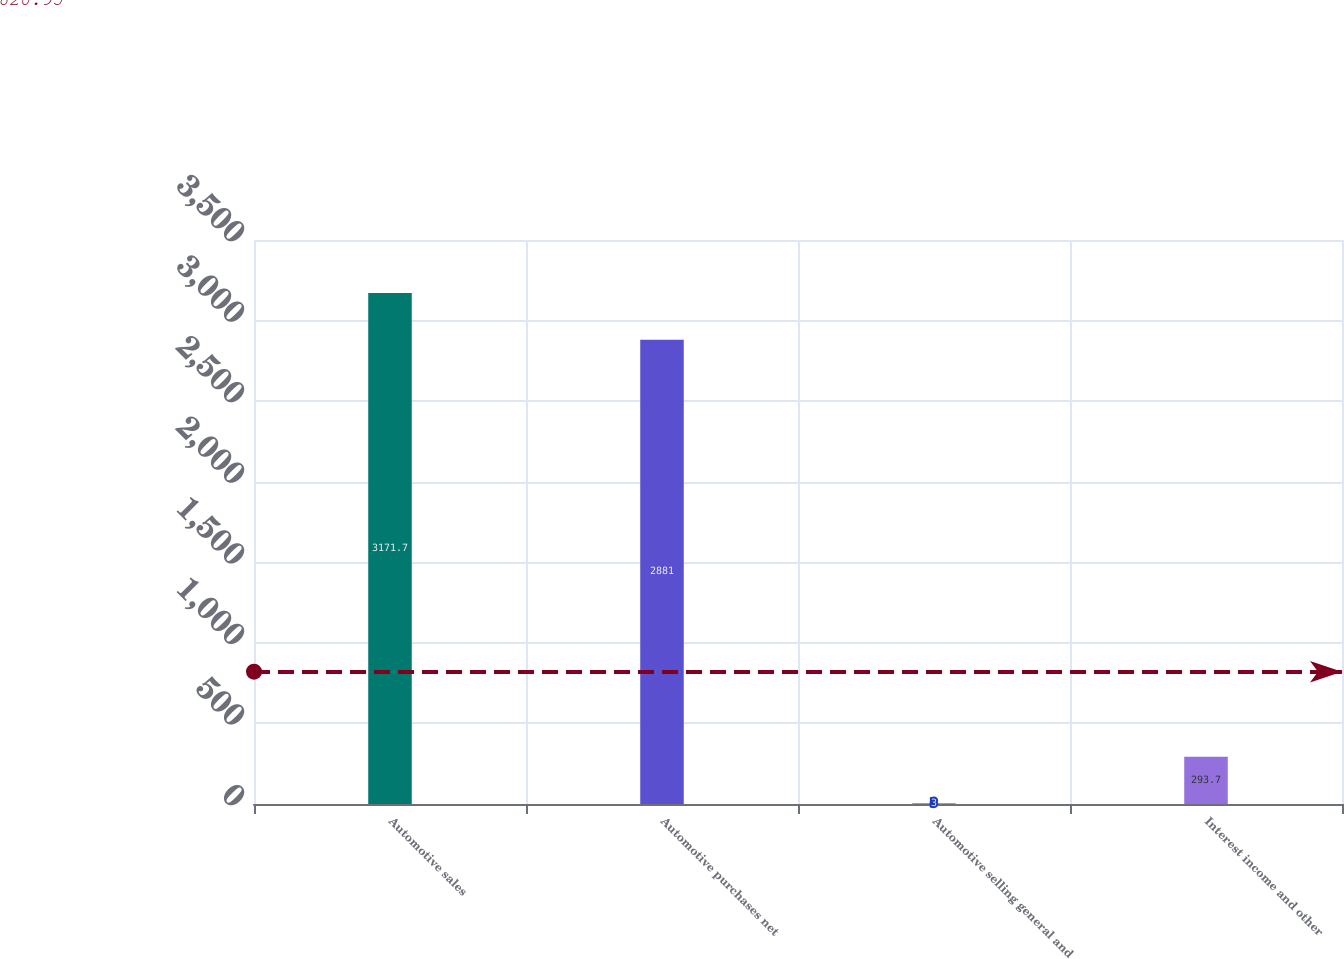Convert chart to OTSL. <chart><loc_0><loc_0><loc_500><loc_500><bar_chart><fcel>Automotive sales<fcel>Automotive purchases net<fcel>Automotive selling general and<fcel>Interest income and other<nl><fcel>3171.7<fcel>2881<fcel>3<fcel>293.7<nl></chart> 